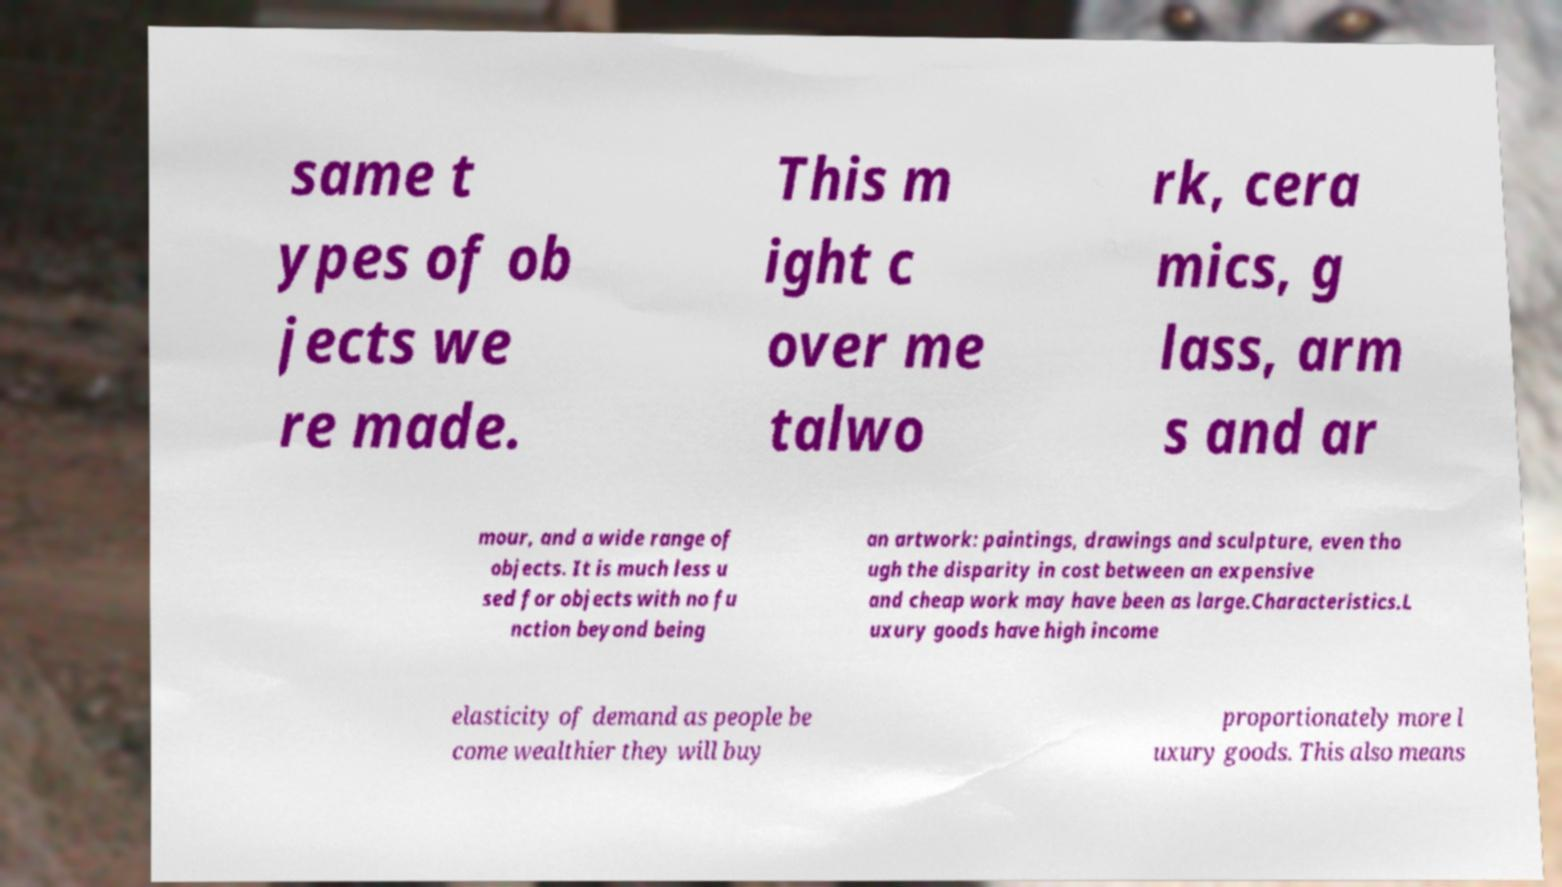Please identify and transcribe the text found in this image. same t ypes of ob jects we re made. This m ight c over me talwo rk, cera mics, g lass, arm s and ar mour, and a wide range of objects. It is much less u sed for objects with no fu nction beyond being an artwork: paintings, drawings and sculpture, even tho ugh the disparity in cost between an expensive and cheap work may have been as large.Characteristics.L uxury goods have high income elasticity of demand as people be come wealthier they will buy proportionately more l uxury goods. This also means 